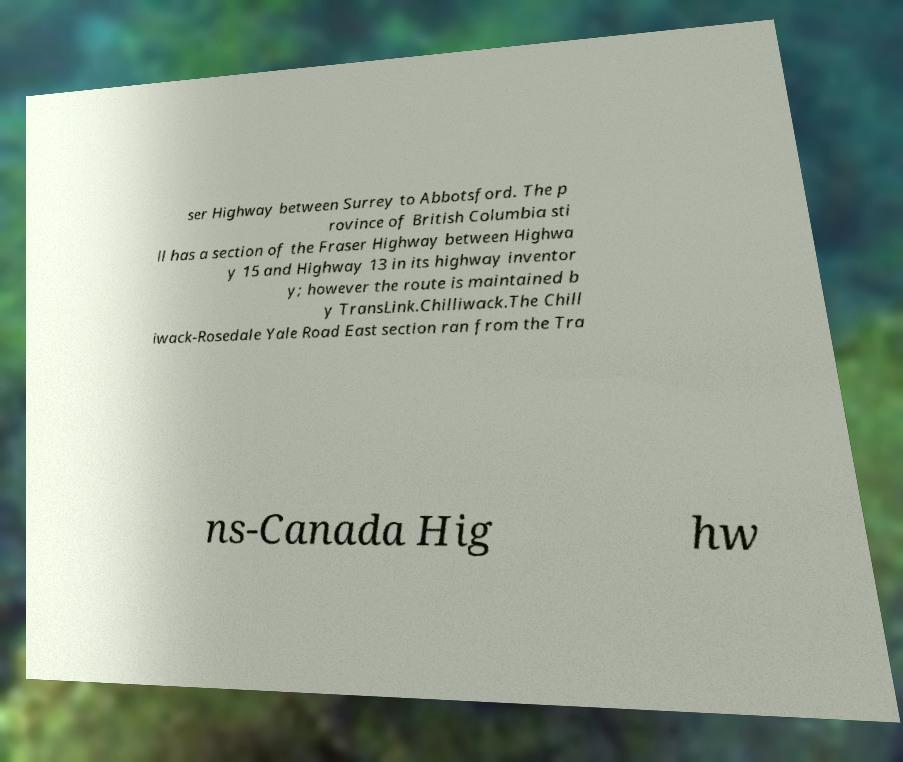Can you read and provide the text displayed in the image?This photo seems to have some interesting text. Can you extract and type it out for me? ser Highway between Surrey to Abbotsford. The p rovince of British Columbia sti ll has a section of the Fraser Highway between Highwa y 15 and Highway 13 in its highway inventor y; however the route is maintained b y TransLink.Chilliwack.The Chill iwack-Rosedale Yale Road East section ran from the Tra ns-Canada Hig hw 